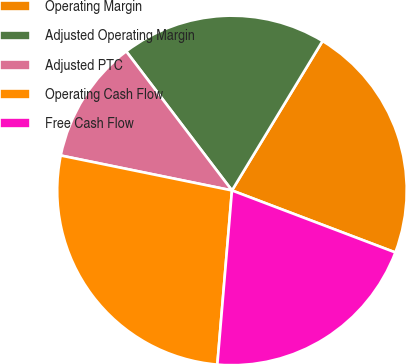<chart> <loc_0><loc_0><loc_500><loc_500><pie_chart><fcel>Operating Margin<fcel>Adjusted Operating Margin<fcel>Adjusted PTC<fcel>Operating Cash Flow<fcel>Free Cash Flow<nl><fcel>22.1%<fcel>19.02%<fcel>11.45%<fcel>26.87%<fcel>20.56%<nl></chart> 